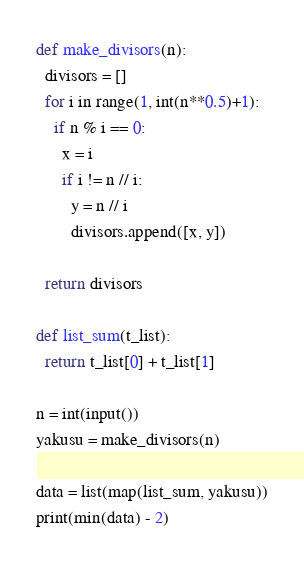Convert code to text. <code><loc_0><loc_0><loc_500><loc_500><_Python_>def make_divisors(n):
  divisors = []
  for i in range(1, int(n**0.5)+1):
    if n % i == 0:
      x = i
      if i != n // i:
        y = n // i
        divisors.append([x, y])

  return divisors

def list_sum(t_list):
  return t_list[0] + t_list[1]

n = int(input())
yakusu = make_divisors(n)

data = list(map(list_sum, yakusu))
print(min(data) - 2)
</code> 